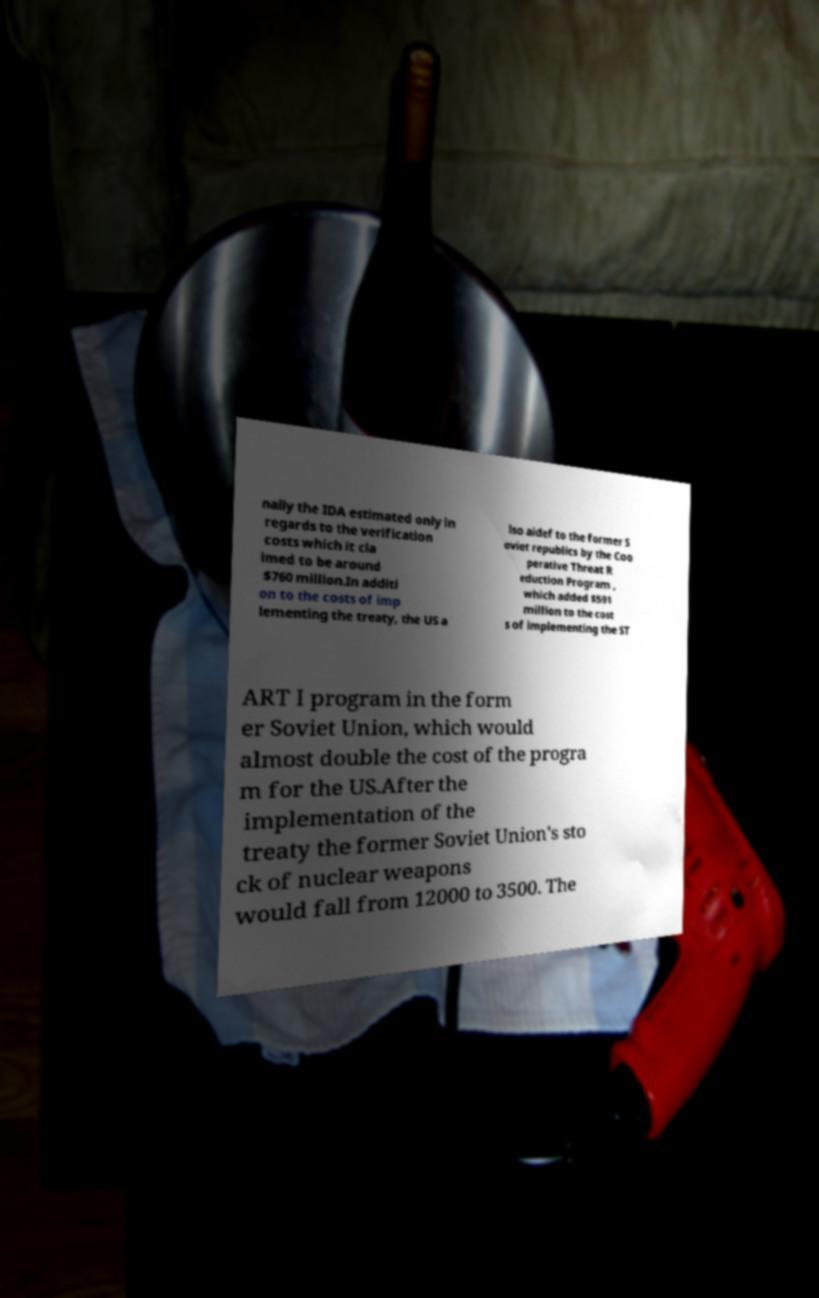I need the written content from this picture converted into text. Can you do that? nally the IDA estimated only in regards to the verification costs which it cla imed to be around $760 million.In additi on to the costs of imp lementing the treaty, the US a lso aidef to the former S oviet republics by the Coo perative Threat R eduction Program , which added $591 million to the cost s of implementing the ST ART I program in the form er Soviet Union, which would almost double the cost of the progra m for the US.After the implementation of the treaty the former Soviet Union's sto ck of nuclear weapons would fall from 12000 to 3500. The 